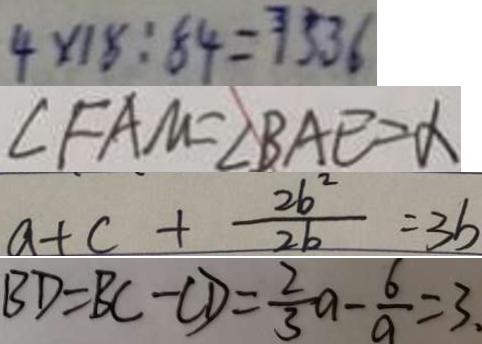<formula> <loc_0><loc_0><loc_500><loc_500>4 \times 1 8 : 8 4 = 7 5 . 3 6 
 \angle F A M = \angle B A E = \alpha 
 a + c + \frac { 2 b ^ { 2 } } { 2 b } = 3 b 
 B D = B C - C D = \frac { 2 } { 3 } a - \frac { 6 } { a } = 3 .</formula> 